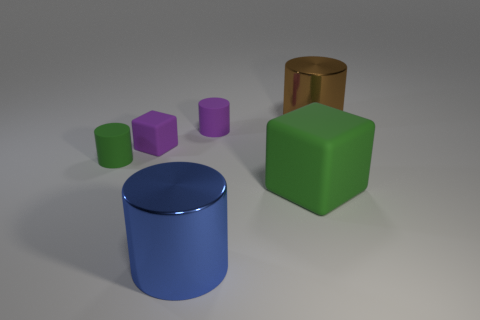Are the tiny cylinder on the left side of the blue thing and the big brown cylinder made of the same material?
Offer a very short reply. No. Is there anything else that has the same size as the blue object?
Your response must be concise. Yes. There is a big cylinder on the left side of the brown cylinder that is right of the large green matte thing; what is it made of?
Keep it short and to the point. Metal. Are there more purple things behind the brown cylinder than metal things in front of the big blue cylinder?
Ensure brevity in your answer.  No. What is the size of the brown cylinder?
Your answer should be compact. Large. There is a shiny cylinder that is on the left side of the big brown shiny thing; is it the same color as the large matte cube?
Offer a very short reply. No. Is there any other thing that has the same shape as the large blue metallic thing?
Make the answer very short. Yes. Is there a purple object that is on the right side of the shiny thing that is behind the large green thing?
Your answer should be compact. No. Are there fewer rubber blocks that are in front of the brown shiny object than tiny matte cylinders that are left of the large green block?
Your answer should be very brief. No. There is a purple rubber thing in front of the tiny purple rubber object that is on the right side of the shiny thing in front of the large brown thing; how big is it?
Your answer should be compact. Small. 